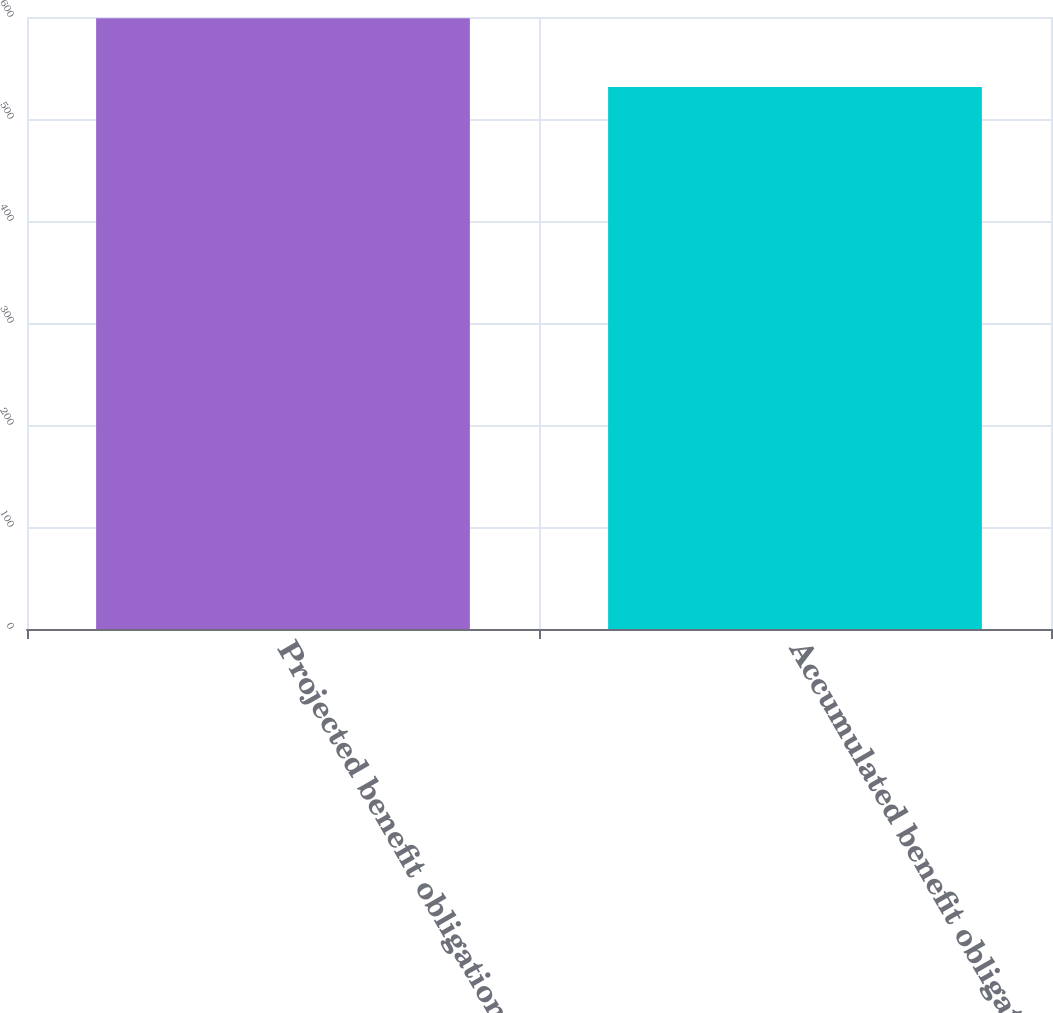Convert chart to OTSL. <chart><loc_0><loc_0><loc_500><loc_500><bar_chart><fcel>Projected benefit obligation<fcel>Accumulated benefit obligation<nl><fcel>598.7<fcel>531.4<nl></chart> 